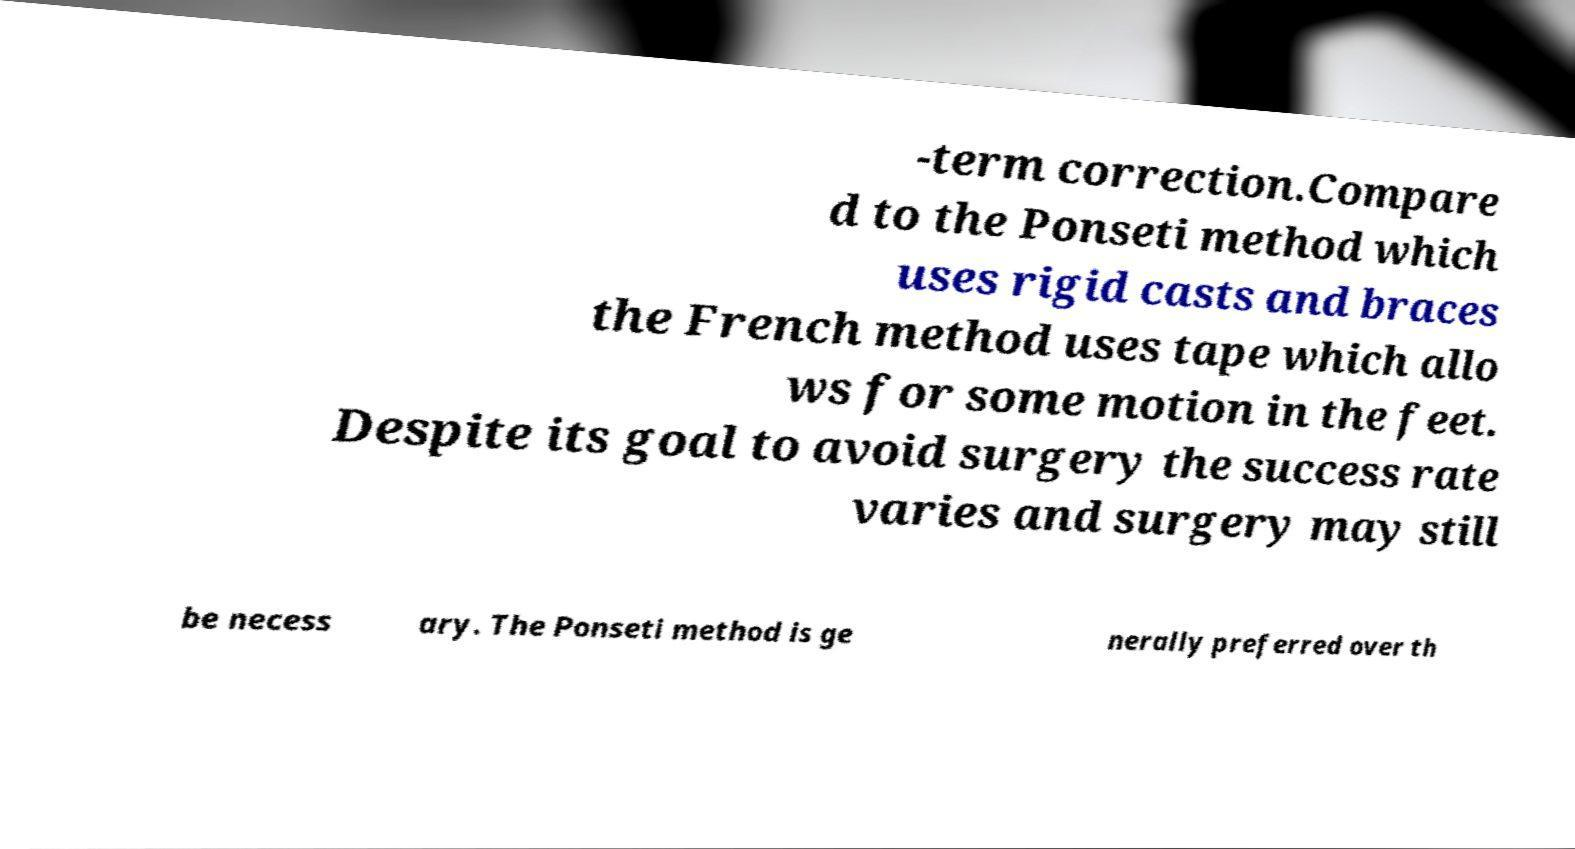I need the written content from this picture converted into text. Can you do that? -term correction.Compare d to the Ponseti method which uses rigid casts and braces the French method uses tape which allo ws for some motion in the feet. Despite its goal to avoid surgery the success rate varies and surgery may still be necess ary. The Ponseti method is ge nerally preferred over th 